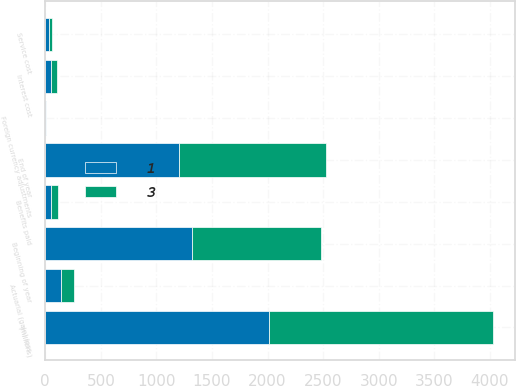Convert chart to OTSL. <chart><loc_0><loc_0><loc_500><loc_500><stacked_bar_chart><ecel><fcel>(millions)<fcel>Beginning of year<fcel>Service cost<fcel>Interest cost<fcel>Actuarial (gain) loss<fcel>Benefits paid<fcel>Foreign currency adjustments<fcel>End of year<nl><fcel>1<fcel>2013<fcel>1323<fcel>34<fcel>50<fcel>145<fcel>56<fcel>5<fcel>1202<nl><fcel>3<fcel>2012<fcel>1155<fcel>27<fcel>53<fcel>115<fcel>62<fcel>1<fcel>1323<nl></chart> 